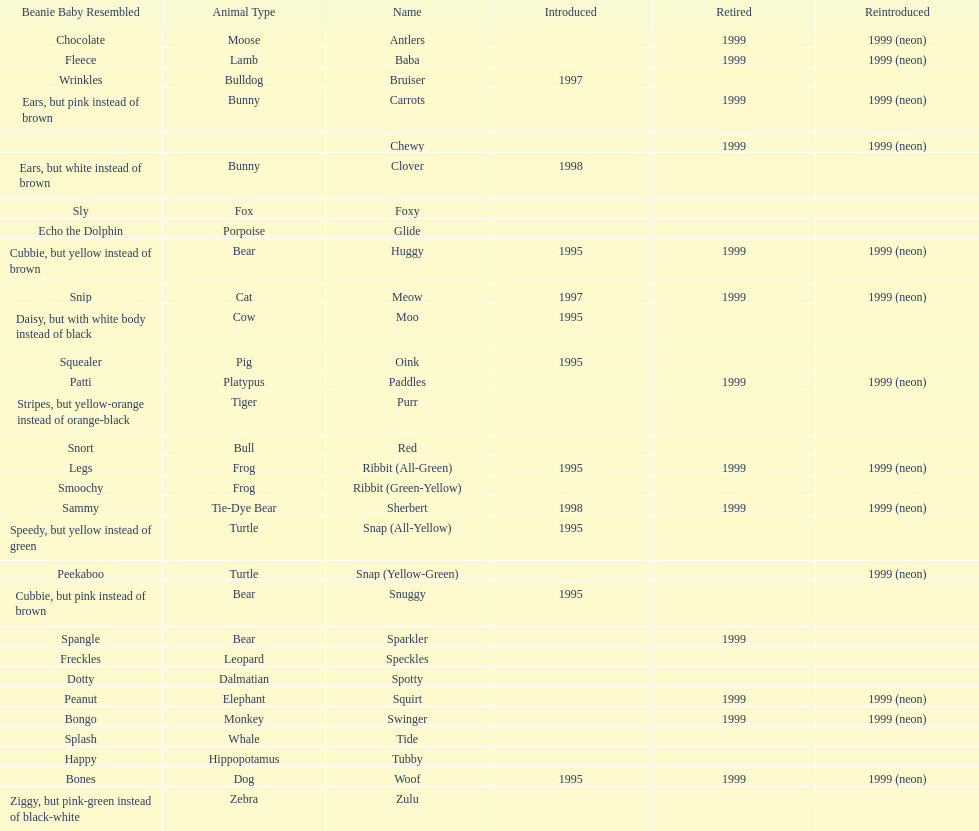What is the total number of pillow pals that were reintroduced as a neon variety? 13. 